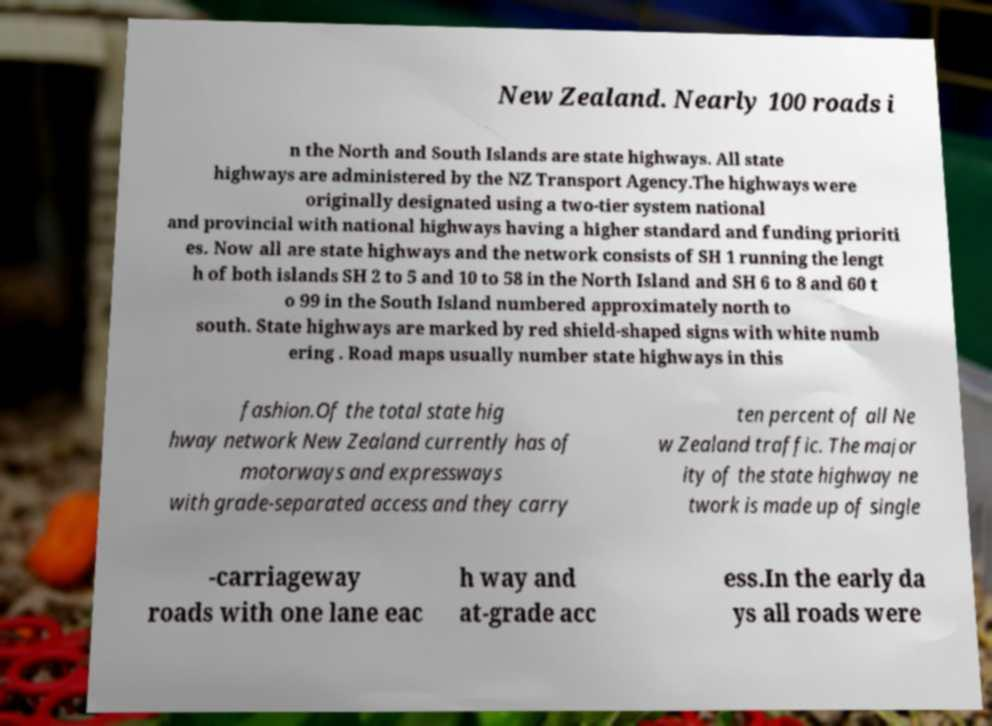Can you accurately transcribe the text from the provided image for me? New Zealand. Nearly 100 roads i n the North and South Islands are state highways. All state highways are administered by the NZ Transport Agency.The highways were originally designated using a two-tier system national and provincial with national highways having a higher standard and funding prioriti es. Now all are state highways and the network consists of SH 1 running the lengt h of both islands SH 2 to 5 and 10 to 58 in the North Island and SH 6 to 8 and 60 t o 99 in the South Island numbered approximately north to south. State highways are marked by red shield-shaped signs with white numb ering . Road maps usually number state highways in this fashion.Of the total state hig hway network New Zealand currently has of motorways and expressways with grade-separated access and they carry ten percent of all Ne w Zealand traffic. The major ity of the state highway ne twork is made up of single -carriageway roads with one lane eac h way and at-grade acc ess.In the early da ys all roads were 